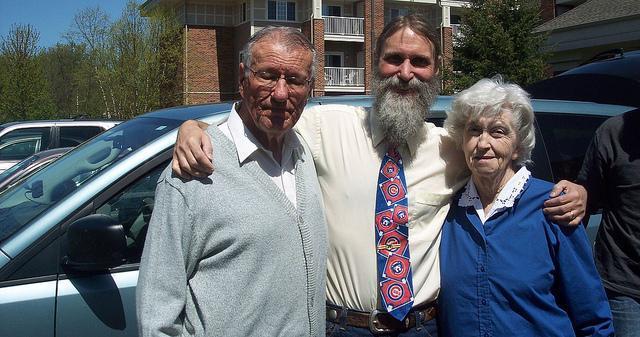How many people have beards?
Give a very brief answer. 1. How many people are wearing a tie?
Give a very brief answer. 1. How many cars are there?
Give a very brief answer. 2. How many people are in the photo?
Give a very brief answer. 4. 